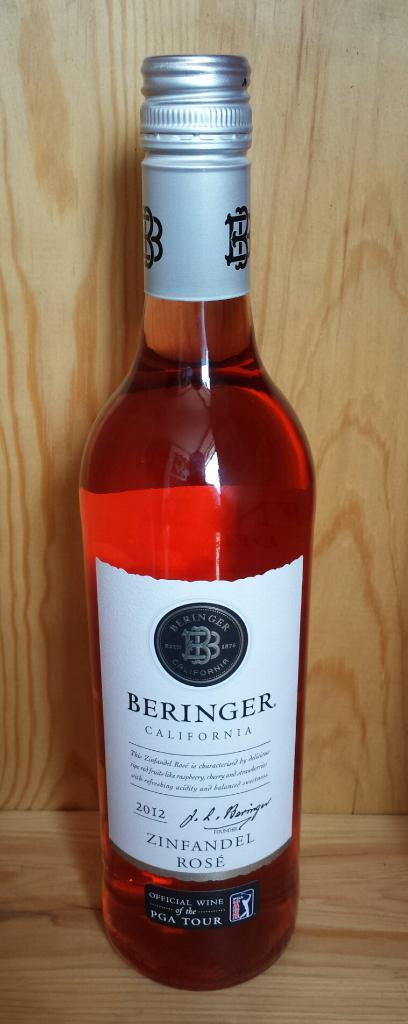Provide a one-sentence caption for the provided image. An unopened bottle of Zinfandel Rose produced by Beringer California. 